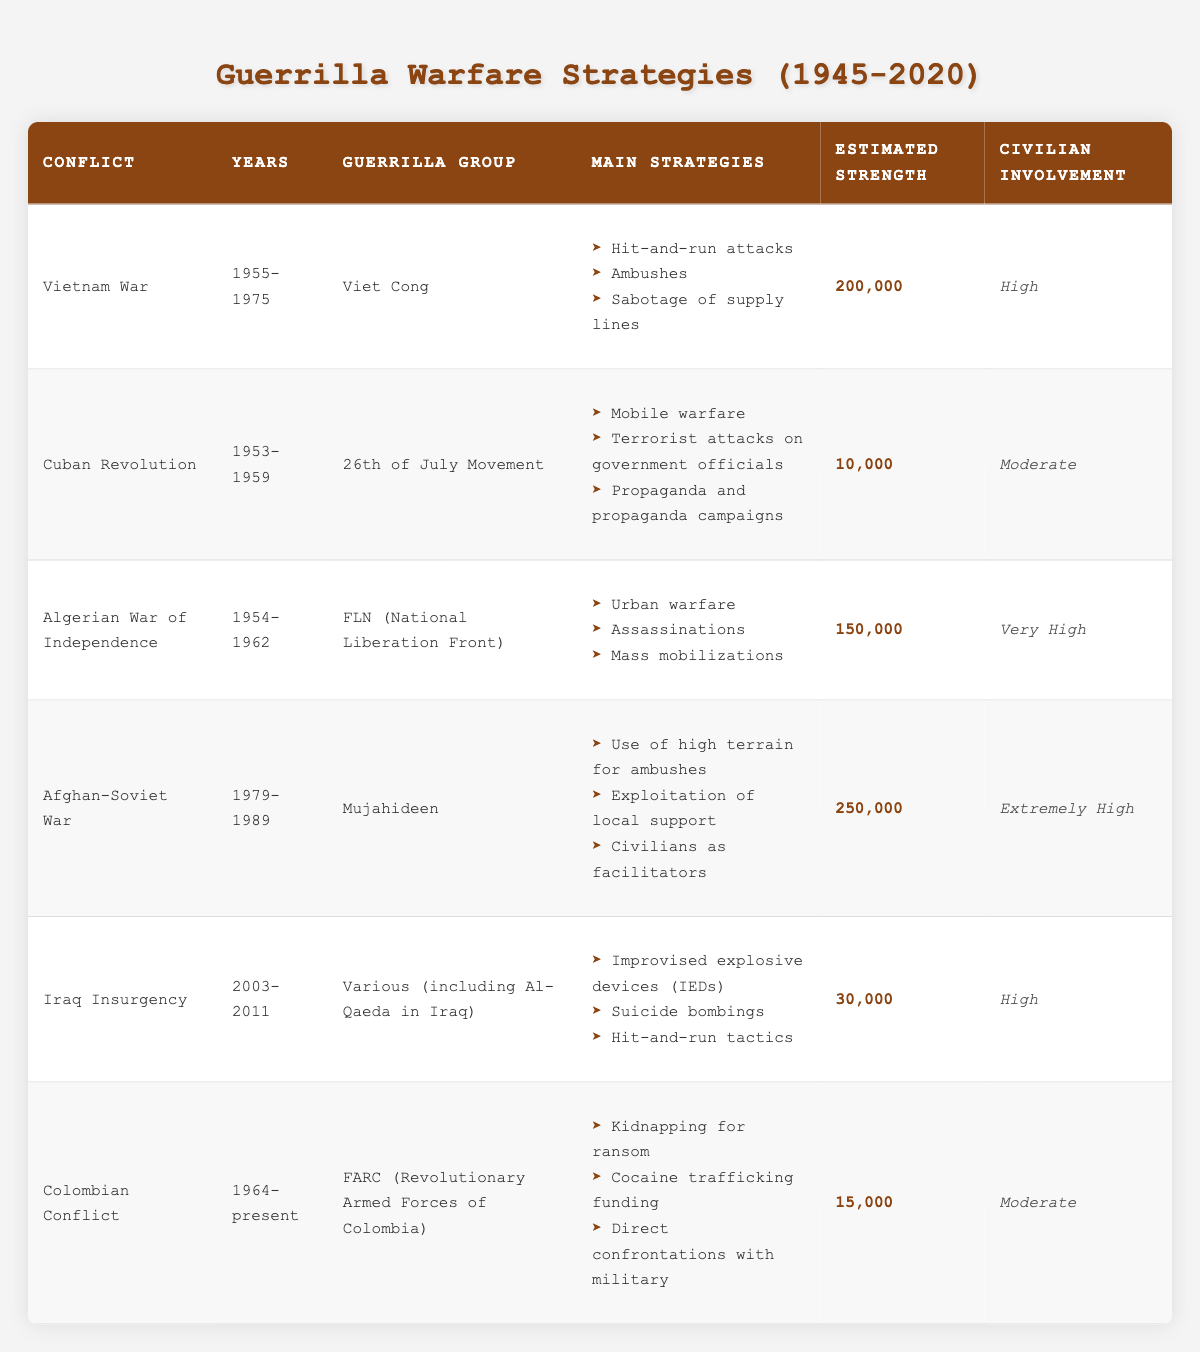What conflict had the highest estimated strength of guerrilla fighters? The estimated strength for each conflict is listed in the table. By examining the values provided, the Afghan-Soviet War shows an estimated strength of 250,000, which is higher than any other listed conflict.
Answer: Afghan-Soviet War Which guerrilla group was involved in the Cuban Revolution? The table specifically lists the guerrilla group associated with the Cuban Revolution, which is the 26th of July Movement as shown in the corresponding row.
Answer: 26th of July Movement Did the Viet Cong have a high level of civilian involvement in the Vietnam War? The table indicates that civilian involvement for the Viet Cong is classified as high. This is a direct reference from the data presented in the relevant row for the Vietnam War.
Answer: Yes What are the main strategies used by the Mujahideen during the Afghan-Soviet War? The table outlines the main strategies utilized by the Mujahideen in the Afghan-Soviet War, which include the use of high terrain for ambushes, exploitation of local support, and civilians as facilitators as listed in that row.
Answer: Use of high terrain for ambushes, exploitation of local support, civilians as facilitators What is the difference in estimated strength between the FLN in the Algerian War and the FARC in the Colombian Conflict? According to the table, the estimated strength of the FLN is 150,000 and for the FARC, it is 15,000. The difference is calculated as 150,000 - 15,000 = 135,000.
Answer: 135,000 How many conflicts involved a guerrilla group with civilian involvement categorized as 'Moderate'? After filtering the table, the conflicts with moderate civilian involvement are the Cuban Revolution and the Colombian Conflict. Thus, there are two conflicts.
Answer: 2 What strategy was common between the insurgents in the Iraq Insurgency and the Viet Cong in the Vietnam War? By comparing the strategies in the table, both groups utilized hit-and-run tactics as one of their main strategies, showing a commonality in their guerrilla warfare approach.
Answer: Hit-and-run tactics Is it true that the FLN's civilian involvement was rated as extremely high? The table explicitly states that civilian involvement for the FLN in the Algerian War is categorized as very high, which means the statement that it is extremely high is incorrect. No, it is not true.
Answer: No What is the average estimated strength of the guerrilla groups listed in the table? To find the average, first sum the estimated strengths: 200,000 + 10,000 + 150,000 + 250,000 + 30,000 + 15,000 = 655,000. Then divide by the number of groups (6) to get an average of 655,000 / 6 ≈ 109,167.
Answer: 109,167 